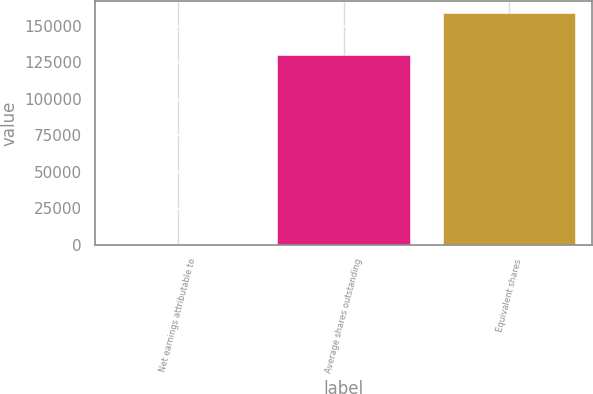Convert chart. <chart><loc_0><loc_0><loc_500><loc_500><bar_chart><fcel>Net earnings attributable to<fcel>Average shares outstanding<fcel>Equivalent shares<nl><fcel>2.2<fcel>130186<fcel>158806<nl></chart> 